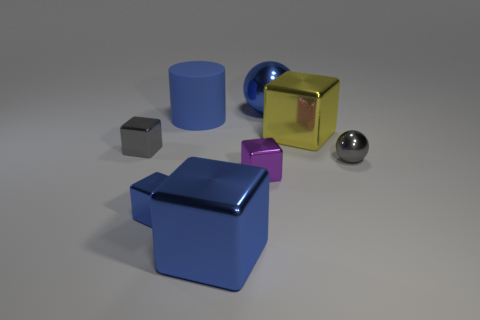Are there any other things that are the same material as the blue cylinder?
Give a very brief answer. No. Does the small purple thing have the same shape as the large yellow shiny thing?
Provide a short and direct response. Yes. There is a blue rubber object that is in front of the blue shiny sphere; what is its size?
Provide a succinct answer. Large. There is a yellow block that is the same material as the purple block; what is its size?
Give a very brief answer. Large. Are there fewer blue things than tiny blue blocks?
Keep it short and to the point. No. There is a cylinder that is the same size as the yellow metal object; what is its material?
Provide a short and direct response. Rubber. Is the number of large rubber spheres greater than the number of cylinders?
Offer a terse response. No. How many other things are there of the same color as the matte thing?
Offer a very short reply. 3. What number of big blue things are both in front of the large blue metallic ball and behind the small purple thing?
Offer a very short reply. 1. Are there more big blue objects that are left of the large blue metal block than blue rubber cylinders in front of the large yellow object?
Offer a very short reply. Yes. 